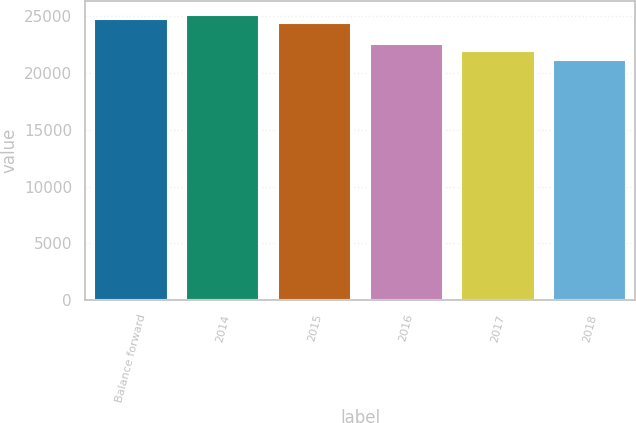Convert chart. <chart><loc_0><loc_0><loc_500><loc_500><bar_chart><fcel>Balance forward<fcel>2014<fcel>2015<fcel>2016<fcel>2017<fcel>2018<nl><fcel>24759.8<fcel>25090.6<fcel>24429<fcel>22551<fcel>21921<fcel>21181<nl></chart> 